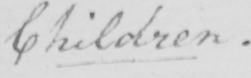Please transcribe the handwritten text in this image. Children . 